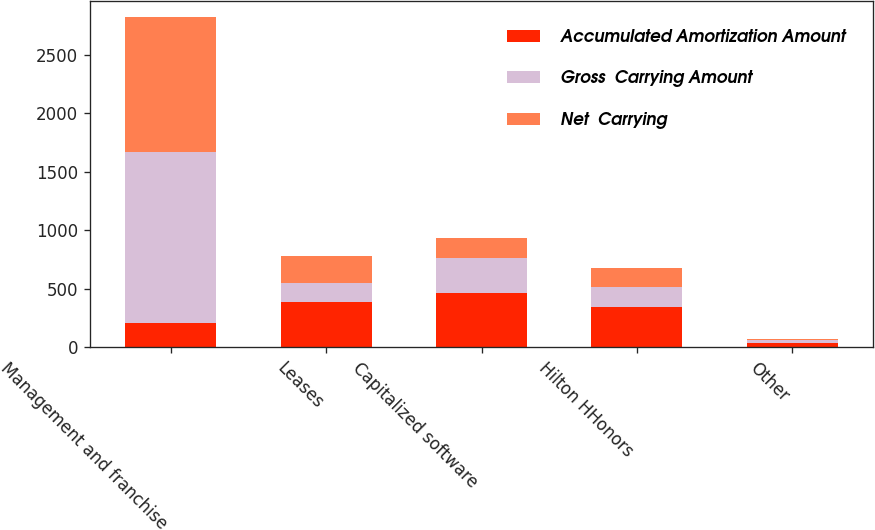<chart> <loc_0><loc_0><loc_500><loc_500><stacked_bar_chart><ecel><fcel>Management and franchise<fcel>Leases<fcel>Capitalized software<fcel>Hilton HHonors<fcel>Other<nl><fcel>Accumulated Amortization Amount<fcel>204.5<fcel>390<fcel>468<fcel>341<fcel>38<nl><fcel>Gross  Carrying Amount<fcel>1467<fcel>156<fcel>293<fcel>174<fcel>28<nl><fcel>Net  Carrying<fcel>1149<fcel>234<fcel>175<fcel>167<fcel>10<nl></chart> 